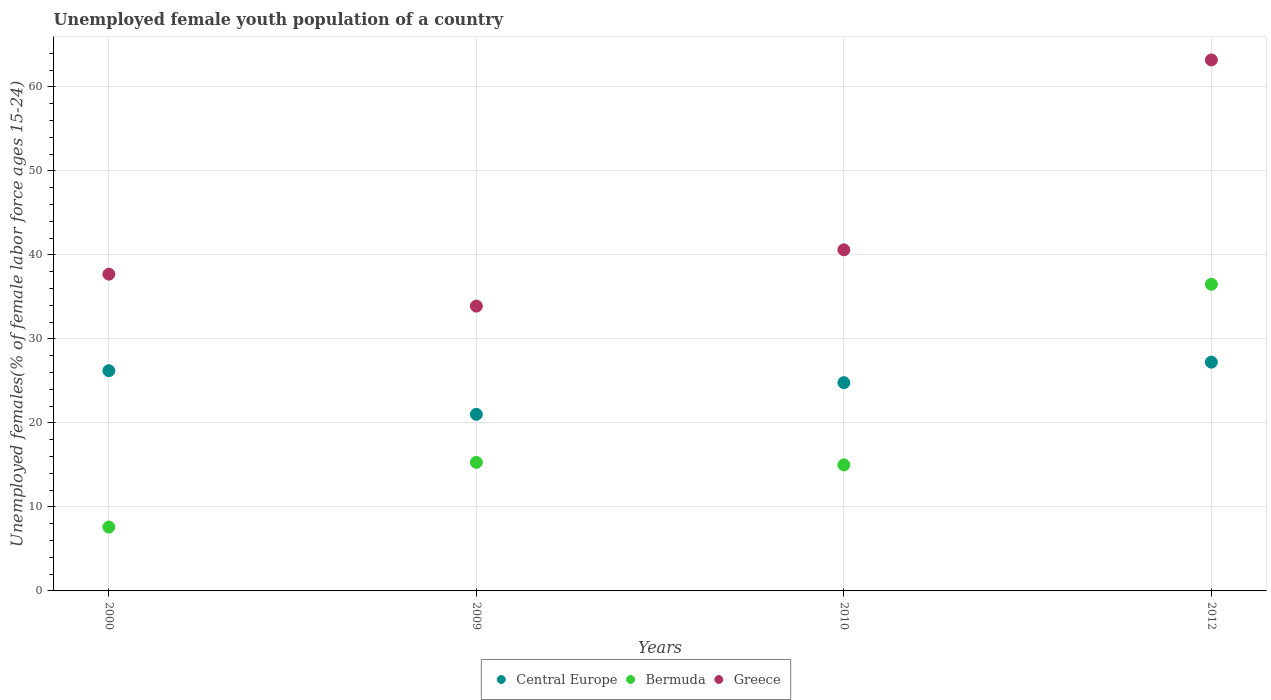What is the percentage of unemployed female youth population in Greece in 2009?
Offer a terse response. 33.9. Across all years, what is the maximum percentage of unemployed female youth population in Bermuda?
Ensure brevity in your answer.  36.5. Across all years, what is the minimum percentage of unemployed female youth population in Greece?
Offer a terse response. 33.9. In which year was the percentage of unemployed female youth population in Bermuda maximum?
Offer a very short reply. 2012. In which year was the percentage of unemployed female youth population in Bermuda minimum?
Provide a short and direct response. 2000. What is the total percentage of unemployed female youth population in Bermuda in the graph?
Make the answer very short. 74.4. What is the difference between the percentage of unemployed female youth population in Greece in 2009 and that in 2010?
Offer a terse response. -6.7. What is the difference between the percentage of unemployed female youth population in Bermuda in 2000 and the percentage of unemployed female youth population in Greece in 2012?
Provide a succinct answer. -55.6. What is the average percentage of unemployed female youth population in Bermuda per year?
Offer a terse response. 18.6. In the year 2000, what is the difference between the percentage of unemployed female youth population in Bermuda and percentage of unemployed female youth population in Greece?
Provide a succinct answer. -30.1. What is the ratio of the percentage of unemployed female youth population in Bermuda in 2000 to that in 2012?
Make the answer very short. 0.21. What is the difference between the highest and the second highest percentage of unemployed female youth population in Central Europe?
Ensure brevity in your answer.  1.02. What is the difference between the highest and the lowest percentage of unemployed female youth population in Bermuda?
Provide a short and direct response. 28.9. Is the sum of the percentage of unemployed female youth population in Bermuda in 2009 and 2012 greater than the maximum percentage of unemployed female youth population in Central Europe across all years?
Provide a short and direct response. Yes. Is it the case that in every year, the sum of the percentage of unemployed female youth population in Greece and percentage of unemployed female youth population in Bermuda  is greater than the percentage of unemployed female youth population in Central Europe?
Keep it short and to the point. Yes. Does the percentage of unemployed female youth population in Bermuda monotonically increase over the years?
Your answer should be very brief. No. Is the percentage of unemployed female youth population in Greece strictly greater than the percentage of unemployed female youth population in Bermuda over the years?
Your answer should be compact. Yes. Is the percentage of unemployed female youth population in Bermuda strictly less than the percentage of unemployed female youth population in Central Europe over the years?
Offer a very short reply. No. How many dotlines are there?
Ensure brevity in your answer.  3. How many years are there in the graph?
Keep it short and to the point. 4. Does the graph contain any zero values?
Offer a very short reply. No. Where does the legend appear in the graph?
Provide a short and direct response. Bottom center. How many legend labels are there?
Give a very brief answer. 3. How are the legend labels stacked?
Offer a very short reply. Horizontal. What is the title of the graph?
Ensure brevity in your answer.  Unemployed female youth population of a country. What is the label or title of the X-axis?
Ensure brevity in your answer.  Years. What is the label or title of the Y-axis?
Provide a short and direct response. Unemployed females(% of female labor force ages 15-24). What is the Unemployed females(% of female labor force ages 15-24) in Central Europe in 2000?
Your response must be concise. 26.21. What is the Unemployed females(% of female labor force ages 15-24) in Bermuda in 2000?
Your answer should be very brief. 7.6. What is the Unemployed females(% of female labor force ages 15-24) in Greece in 2000?
Make the answer very short. 37.7. What is the Unemployed females(% of female labor force ages 15-24) in Central Europe in 2009?
Your answer should be compact. 21.02. What is the Unemployed females(% of female labor force ages 15-24) of Bermuda in 2009?
Keep it short and to the point. 15.3. What is the Unemployed females(% of female labor force ages 15-24) of Greece in 2009?
Give a very brief answer. 33.9. What is the Unemployed females(% of female labor force ages 15-24) in Central Europe in 2010?
Offer a very short reply. 24.79. What is the Unemployed females(% of female labor force ages 15-24) of Bermuda in 2010?
Keep it short and to the point. 15. What is the Unemployed females(% of female labor force ages 15-24) of Greece in 2010?
Provide a succinct answer. 40.6. What is the Unemployed females(% of female labor force ages 15-24) in Central Europe in 2012?
Your answer should be compact. 27.23. What is the Unemployed females(% of female labor force ages 15-24) of Bermuda in 2012?
Offer a very short reply. 36.5. What is the Unemployed females(% of female labor force ages 15-24) of Greece in 2012?
Offer a very short reply. 63.2. Across all years, what is the maximum Unemployed females(% of female labor force ages 15-24) in Central Europe?
Offer a very short reply. 27.23. Across all years, what is the maximum Unemployed females(% of female labor force ages 15-24) of Bermuda?
Ensure brevity in your answer.  36.5. Across all years, what is the maximum Unemployed females(% of female labor force ages 15-24) in Greece?
Your response must be concise. 63.2. Across all years, what is the minimum Unemployed females(% of female labor force ages 15-24) of Central Europe?
Your answer should be very brief. 21.02. Across all years, what is the minimum Unemployed females(% of female labor force ages 15-24) in Bermuda?
Offer a terse response. 7.6. Across all years, what is the minimum Unemployed females(% of female labor force ages 15-24) in Greece?
Ensure brevity in your answer.  33.9. What is the total Unemployed females(% of female labor force ages 15-24) of Central Europe in the graph?
Your answer should be very brief. 99.25. What is the total Unemployed females(% of female labor force ages 15-24) in Bermuda in the graph?
Give a very brief answer. 74.4. What is the total Unemployed females(% of female labor force ages 15-24) of Greece in the graph?
Offer a terse response. 175.4. What is the difference between the Unemployed females(% of female labor force ages 15-24) in Central Europe in 2000 and that in 2009?
Your response must be concise. 5.19. What is the difference between the Unemployed females(% of female labor force ages 15-24) in Bermuda in 2000 and that in 2009?
Your answer should be very brief. -7.7. What is the difference between the Unemployed females(% of female labor force ages 15-24) in Central Europe in 2000 and that in 2010?
Make the answer very short. 1.42. What is the difference between the Unemployed females(% of female labor force ages 15-24) of Bermuda in 2000 and that in 2010?
Provide a succinct answer. -7.4. What is the difference between the Unemployed females(% of female labor force ages 15-24) in Central Europe in 2000 and that in 2012?
Provide a short and direct response. -1.02. What is the difference between the Unemployed females(% of female labor force ages 15-24) in Bermuda in 2000 and that in 2012?
Make the answer very short. -28.9. What is the difference between the Unemployed females(% of female labor force ages 15-24) in Greece in 2000 and that in 2012?
Offer a very short reply. -25.5. What is the difference between the Unemployed females(% of female labor force ages 15-24) of Central Europe in 2009 and that in 2010?
Your answer should be compact. -3.76. What is the difference between the Unemployed females(% of female labor force ages 15-24) of Bermuda in 2009 and that in 2010?
Your answer should be very brief. 0.3. What is the difference between the Unemployed females(% of female labor force ages 15-24) of Greece in 2009 and that in 2010?
Make the answer very short. -6.7. What is the difference between the Unemployed females(% of female labor force ages 15-24) of Central Europe in 2009 and that in 2012?
Your answer should be compact. -6.21. What is the difference between the Unemployed females(% of female labor force ages 15-24) of Bermuda in 2009 and that in 2012?
Provide a succinct answer. -21.2. What is the difference between the Unemployed females(% of female labor force ages 15-24) in Greece in 2009 and that in 2012?
Offer a terse response. -29.3. What is the difference between the Unemployed females(% of female labor force ages 15-24) in Central Europe in 2010 and that in 2012?
Your answer should be very brief. -2.44. What is the difference between the Unemployed females(% of female labor force ages 15-24) in Bermuda in 2010 and that in 2012?
Make the answer very short. -21.5. What is the difference between the Unemployed females(% of female labor force ages 15-24) of Greece in 2010 and that in 2012?
Ensure brevity in your answer.  -22.6. What is the difference between the Unemployed females(% of female labor force ages 15-24) in Central Europe in 2000 and the Unemployed females(% of female labor force ages 15-24) in Bermuda in 2009?
Offer a terse response. 10.91. What is the difference between the Unemployed females(% of female labor force ages 15-24) in Central Europe in 2000 and the Unemployed females(% of female labor force ages 15-24) in Greece in 2009?
Make the answer very short. -7.69. What is the difference between the Unemployed females(% of female labor force ages 15-24) in Bermuda in 2000 and the Unemployed females(% of female labor force ages 15-24) in Greece in 2009?
Your answer should be very brief. -26.3. What is the difference between the Unemployed females(% of female labor force ages 15-24) in Central Europe in 2000 and the Unemployed females(% of female labor force ages 15-24) in Bermuda in 2010?
Provide a short and direct response. 11.21. What is the difference between the Unemployed females(% of female labor force ages 15-24) in Central Europe in 2000 and the Unemployed females(% of female labor force ages 15-24) in Greece in 2010?
Make the answer very short. -14.39. What is the difference between the Unemployed females(% of female labor force ages 15-24) in Bermuda in 2000 and the Unemployed females(% of female labor force ages 15-24) in Greece in 2010?
Your answer should be very brief. -33. What is the difference between the Unemployed females(% of female labor force ages 15-24) of Central Europe in 2000 and the Unemployed females(% of female labor force ages 15-24) of Bermuda in 2012?
Make the answer very short. -10.29. What is the difference between the Unemployed females(% of female labor force ages 15-24) in Central Europe in 2000 and the Unemployed females(% of female labor force ages 15-24) in Greece in 2012?
Your answer should be compact. -36.99. What is the difference between the Unemployed females(% of female labor force ages 15-24) in Bermuda in 2000 and the Unemployed females(% of female labor force ages 15-24) in Greece in 2012?
Provide a short and direct response. -55.6. What is the difference between the Unemployed females(% of female labor force ages 15-24) in Central Europe in 2009 and the Unemployed females(% of female labor force ages 15-24) in Bermuda in 2010?
Give a very brief answer. 6.02. What is the difference between the Unemployed females(% of female labor force ages 15-24) in Central Europe in 2009 and the Unemployed females(% of female labor force ages 15-24) in Greece in 2010?
Offer a very short reply. -19.58. What is the difference between the Unemployed females(% of female labor force ages 15-24) in Bermuda in 2009 and the Unemployed females(% of female labor force ages 15-24) in Greece in 2010?
Ensure brevity in your answer.  -25.3. What is the difference between the Unemployed females(% of female labor force ages 15-24) of Central Europe in 2009 and the Unemployed females(% of female labor force ages 15-24) of Bermuda in 2012?
Ensure brevity in your answer.  -15.48. What is the difference between the Unemployed females(% of female labor force ages 15-24) of Central Europe in 2009 and the Unemployed females(% of female labor force ages 15-24) of Greece in 2012?
Make the answer very short. -42.18. What is the difference between the Unemployed females(% of female labor force ages 15-24) in Bermuda in 2009 and the Unemployed females(% of female labor force ages 15-24) in Greece in 2012?
Provide a short and direct response. -47.9. What is the difference between the Unemployed females(% of female labor force ages 15-24) of Central Europe in 2010 and the Unemployed females(% of female labor force ages 15-24) of Bermuda in 2012?
Provide a short and direct response. -11.71. What is the difference between the Unemployed females(% of female labor force ages 15-24) in Central Europe in 2010 and the Unemployed females(% of female labor force ages 15-24) in Greece in 2012?
Keep it short and to the point. -38.41. What is the difference between the Unemployed females(% of female labor force ages 15-24) in Bermuda in 2010 and the Unemployed females(% of female labor force ages 15-24) in Greece in 2012?
Offer a very short reply. -48.2. What is the average Unemployed females(% of female labor force ages 15-24) in Central Europe per year?
Provide a succinct answer. 24.81. What is the average Unemployed females(% of female labor force ages 15-24) of Bermuda per year?
Offer a very short reply. 18.6. What is the average Unemployed females(% of female labor force ages 15-24) of Greece per year?
Give a very brief answer. 43.85. In the year 2000, what is the difference between the Unemployed females(% of female labor force ages 15-24) of Central Europe and Unemployed females(% of female labor force ages 15-24) of Bermuda?
Your answer should be compact. 18.61. In the year 2000, what is the difference between the Unemployed females(% of female labor force ages 15-24) in Central Europe and Unemployed females(% of female labor force ages 15-24) in Greece?
Offer a very short reply. -11.49. In the year 2000, what is the difference between the Unemployed females(% of female labor force ages 15-24) of Bermuda and Unemployed females(% of female labor force ages 15-24) of Greece?
Make the answer very short. -30.1. In the year 2009, what is the difference between the Unemployed females(% of female labor force ages 15-24) of Central Europe and Unemployed females(% of female labor force ages 15-24) of Bermuda?
Offer a terse response. 5.72. In the year 2009, what is the difference between the Unemployed females(% of female labor force ages 15-24) in Central Europe and Unemployed females(% of female labor force ages 15-24) in Greece?
Offer a terse response. -12.88. In the year 2009, what is the difference between the Unemployed females(% of female labor force ages 15-24) of Bermuda and Unemployed females(% of female labor force ages 15-24) of Greece?
Give a very brief answer. -18.6. In the year 2010, what is the difference between the Unemployed females(% of female labor force ages 15-24) of Central Europe and Unemployed females(% of female labor force ages 15-24) of Bermuda?
Your response must be concise. 9.79. In the year 2010, what is the difference between the Unemployed females(% of female labor force ages 15-24) in Central Europe and Unemployed females(% of female labor force ages 15-24) in Greece?
Offer a very short reply. -15.81. In the year 2010, what is the difference between the Unemployed females(% of female labor force ages 15-24) in Bermuda and Unemployed females(% of female labor force ages 15-24) in Greece?
Ensure brevity in your answer.  -25.6. In the year 2012, what is the difference between the Unemployed females(% of female labor force ages 15-24) of Central Europe and Unemployed females(% of female labor force ages 15-24) of Bermuda?
Your answer should be compact. -9.27. In the year 2012, what is the difference between the Unemployed females(% of female labor force ages 15-24) in Central Europe and Unemployed females(% of female labor force ages 15-24) in Greece?
Keep it short and to the point. -35.97. In the year 2012, what is the difference between the Unemployed females(% of female labor force ages 15-24) in Bermuda and Unemployed females(% of female labor force ages 15-24) in Greece?
Offer a very short reply. -26.7. What is the ratio of the Unemployed females(% of female labor force ages 15-24) in Central Europe in 2000 to that in 2009?
Your answer should be very brief. 1.25. What is the ratio of the Unemployed females(% of female labor force ages 15-24) in Bermuda in 2000 to that in 2009?
Offer a very short reply. 0.5. What is the ratio of the Unemployed females(% of female labor force ages 15-24) of Greece in 2000 to that in 2009?
Provide a short and direct response. 1.11. What is the ratio of the Unemployed females(% of female labor force ages 15-24) of Central Europe in 2000 to that in 2010?
Offer a terse response. 1.06. What is the ratio of the Unemployed females(% of female labor force ages 15-24) of Bermuda in 2000 to that in 2010?
Your response must be concise. 0.51. What is the ratio of the Unemployed females(% of female labor force ages 15-24) in Central Europe in 2000 to that in 2012?
Provide a short and direct response. 0.96. What is the ratio of the Unemployed females(% of female labor force ages 15-24) of Bermuda in 2000 to that in 2012?
Your response must be concise. 0.21. What is the ratio of the Unemployed females(% of female labor force ages 15-24) of Greece in 2000 to that in 2012?
Keep it short and to the point. 0.6. What is the ratio of the Unemployed females(% of female labor force ages 15-24) of Central Europe in 2009 to that in 2010?
Make the answer very short. 0.85. What is the ratio of the Unemployed females(% of female labor force ages 15-24) of Bermuda in 2009 to that in 2010?
Give a very brief answer. 1.02. What is the ratio of the Unemployed females(% of female labor force ages 15-24) of Greece in 2009 to that in 2010?
Your response must be concise. 0.83. What is the ratio of the Unemployed females(% of female labor force ages 15-24) in Central Europe in 2009 to that in 2012?
Provide a short and direct response. 0.77. What is the ratio of the Unemployed females(% of female labor force ages 15-24) of Bermuda in 2009 to that in 2012?
Offer a terse response. 0.42. What is the ratio of the Unemployed females(% of female labor force ages 15-24) of Greece in 2009 to that in 2012?
Ensure brevity in your answer.  0.54. What is the ratio of the Unemployed females(% of female labor force ages 15-24) of Central Europe in 2010 to that in 2012?
Offer a very short reply. 0.91. What is the ratio of the Unemployed females(% of female labor force ages 15-24) in Bermuda in 2010 to that in 2012?
Your answer should be compact. 0.41. What is the ratio of the Unemployed females(% of female labor force ages 15-24) in Greece in 2010 to that in 2012?
Offer a terse response. 0.64. What is the difference between the highest and the second highest Unemployed females(% of female labor force ages 15-24) in Central Europe?
Offer a very short reply. 1.02. What is the difference between the highest and the second highest Unemployed females(% of female labor force ages 15-24) in Bermuda?
Your answer should be compact. 21.2. What is the difference between the highest and the second highest Unemployed females(% of female labor force ages 15-24) of Greece?
Your response must be concise. 22.6. What is the difference between the highest and the lowest Unemployed females(% of female labor force ages 15-24) in Central Europe?
Provide a short and direct response. 6.21. What is the difference between the highest and the lowest Unemployed females(% of female labor force ages 15-24) in Bermuda?
Offer a terse response. 28.9. What is the difference between the highest and the lowest Unemployed females(% of female labor force ages 15-24) in Greece?
Ensure brevity in your answer.  29.3. 